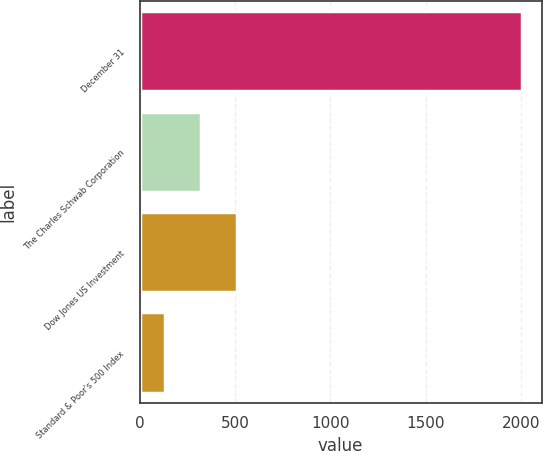Convert chart to OTSL. <chart><loc_0><loc_0><loc_500><loc_500><bar_chart><fcel>December 31<fcel>The Charles Schwab Corporation<fcel>Dow Jones US Investment<fcel>Standard & Poor's 500 Index<nl><fcel>2006<fcel>322.1<fcel>509.2<fcel>135<nl></chart> 